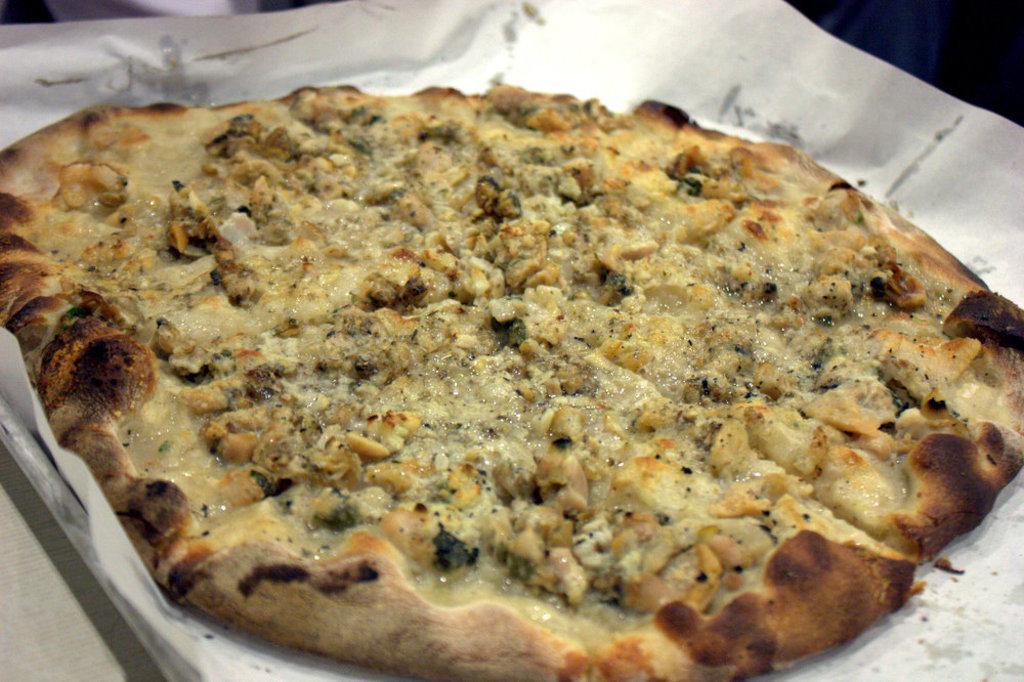Please provide a concise description of this image. In the center of the image there is a pizza on plate placed on the table. 